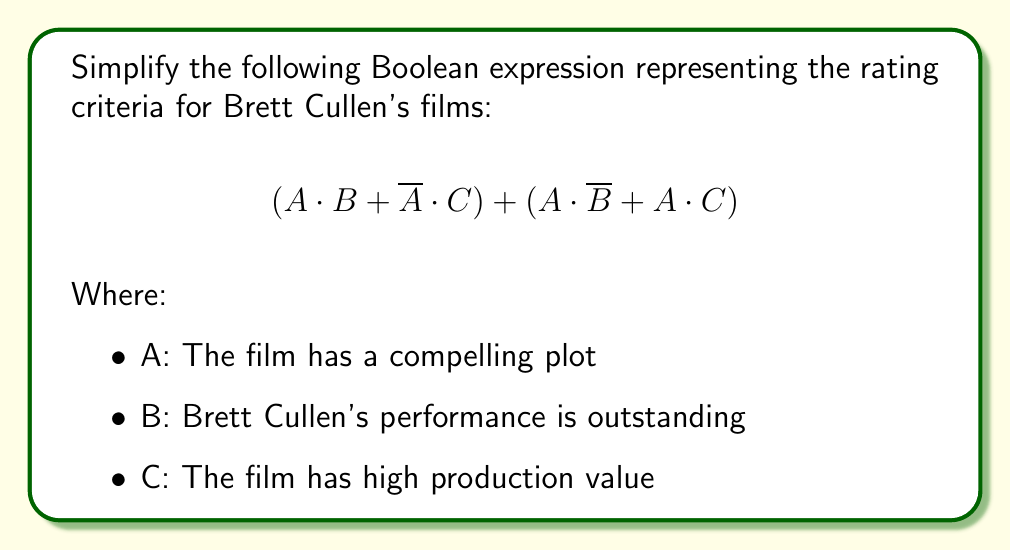Can you solve this math problem? Let's simplify this Boolean expression step by step:

1) First, let's distribute A in the second term:
   $$(A \cdot B + \overline{A} \cdot C) + (A \cdot \overline{B} + A \cdot C)$$
   $$= (A \cdot B + \overline{A} \cdot C) + A \cdot (\overline{B} + C)$$

2) Now, we can apply the distributive law to the whole expression:
   $$= A \cdot B + \overline{A} \cdot C + A \cdot \overline{B} + A \cdot C$$

3) We can rearrange the terms:
   $$= A \cdot B + A \cdot \overline{B} + A \cdot C + \overline{A} \cdot C$$

4) The first two terms $(A \cdot B + A \cdot \overline{B})$ can be simplified using the law of excluded middle:
   $$= A + A \cdot C + \overline{A} \cdot C$$

5) Now, we can factor out C from the last two terms:
   $$= A + C \cdot (A + \overline{A})$$

6) The term $(A + \overline{A})$ always equals 1 (law of excluded middle), so:
   $$= A + C$$

Therefore, the simplified expression is $A + C$.
Answer: $A + C$ 